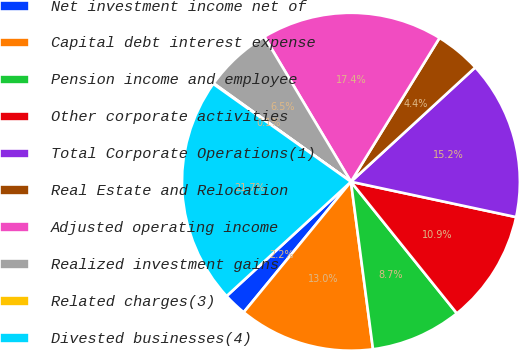Convert chart to OTSL. <chart><loc_0><loc_0><loc_500><loc_500><pie_chart><fcel>Net investment income net of<fcel>Capital debt interest expense<fcel>Pension income and employee<fcel>Other corporate activities<fcel>Total Corporate Operations(1)<fcel>Real Estate and Relocation<fcel>Adjusted operating income<fcel>Realized investment gains<fcel>Related charges(3)<fcel>Divested businesses(4)<nl><fcel>2.22%<fcel>13.03%<fcel>8.7%<fcel>10.86%<fcel>15.19%<fcel>4.38%<fcel>17.35%<fcel>6.54%<fcel>0.06%<fcel>21.67%<nl></chart> 